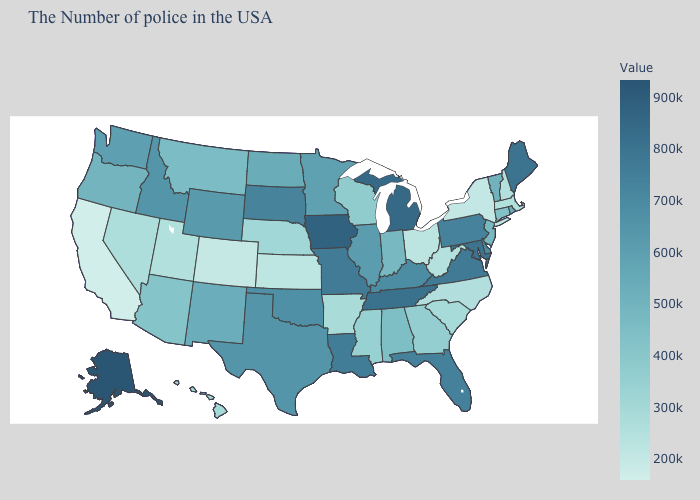Does the map have missing data?
Be succinct. No. Does New Mexico have a lower value than Iowa?
Be succinct. Yes. Among the states that border Oregon , does Washington have the lowest value?
Be succinct. No. Does Tennessee have the highest value in the South?
Quick response, please. Yes. Among the states that border Kansas , which have the highest value?
Quick response, please. Missouri. 